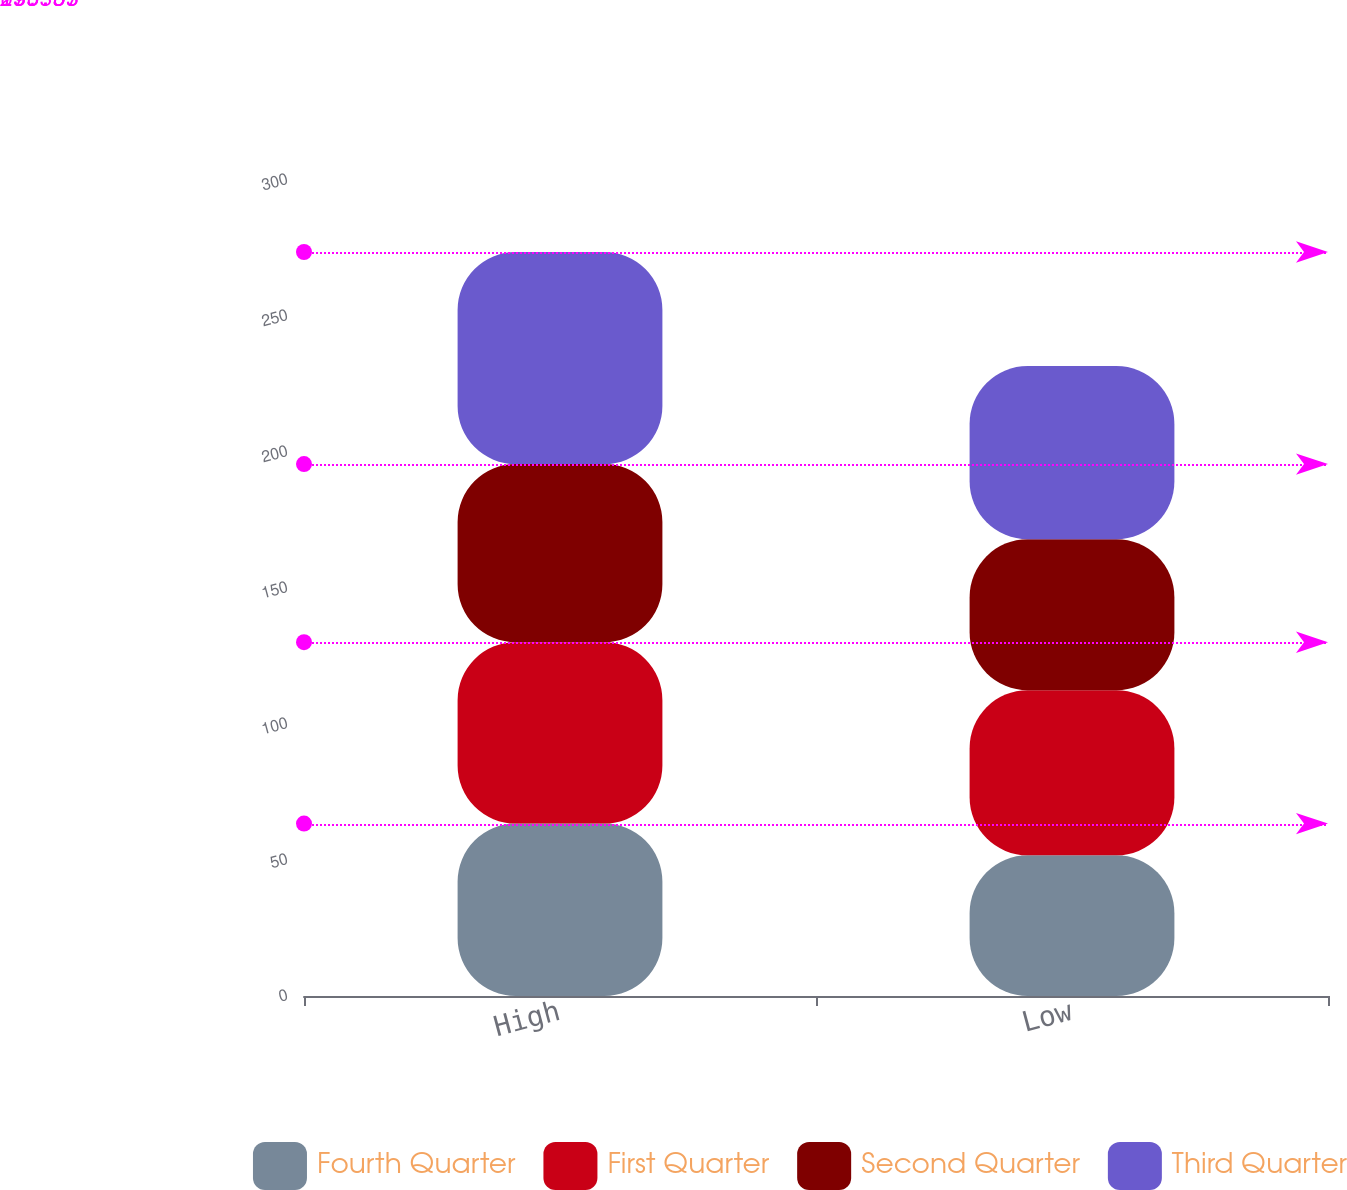Convert chart. <chart><loc_0><loc_0><loc_500><loc_500><stacked_bar_chart><ecel><fcel>High<fcel>Low<nl><fcel>Fourth Quarter<fcel>63.38<fcel>51.73<nl><fcel>First Quarter<fcel>66.69<fcel>60.71<nl><fcel>Second Quarter<fcel>65.48<fcel>55.5<nl><fcel>Third Quarter<fcel>77.98<fcel>63.69<nl></chart> 